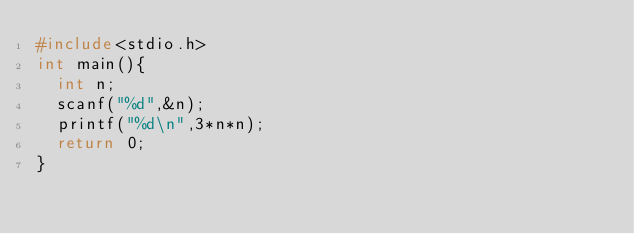Convert code to text. <code><loc_0><loc_0><loc_500><loc_500><_C_>#include<stdio.h>
int main(){
  int n;
  scanf("%d",&n);
  printf("%d\n",3*n*n);
  return 0;
}
</code> 